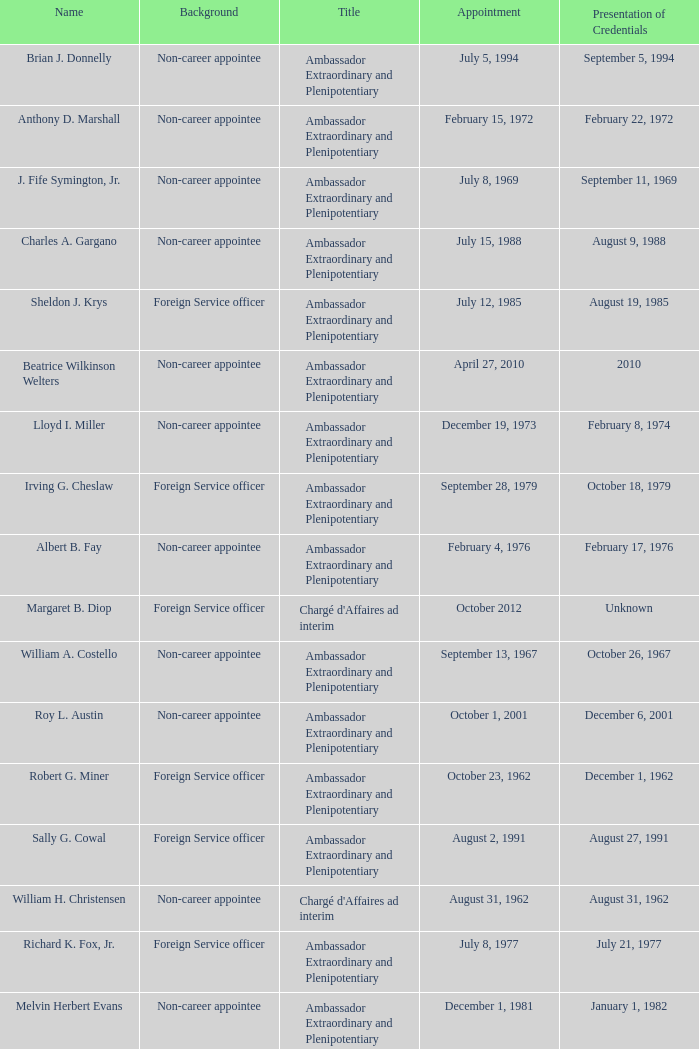Who presented their credentials at an unknown date? Margaret B. Diop. 